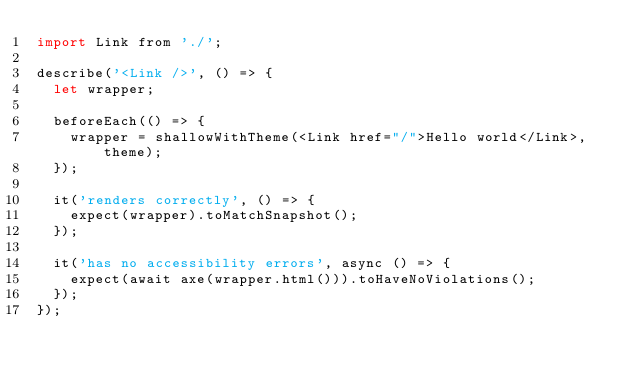Convert code to text. <code><loc_0><loc_0><loc_500><loc_500><_JavaScript_>import Link from './';

describe('<Link />', () => {
  let wrapper;

  beforeEach(() => {
    wrapper = shallowWithTheme(<Link href="/">Hello world</Link>, theme);
  });

  it('renders correctly', () => {
    expect(wrapper).toMatchSnapshot();
  });

  it('has no accessibility errors', async () => {
    expect(await axe(wrapper.html())).toHaveNoViolations();
  });
});
</code> 